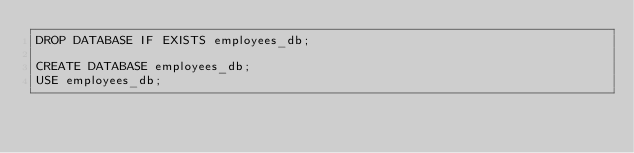Convert code to text. <code><loc_0><loc_0><loc_500><loc_500><_SQL_>DROP DATABASE IF EXISTS employees_db;

CREATE DATABASE employees_db;
USE employees_db;</code> 